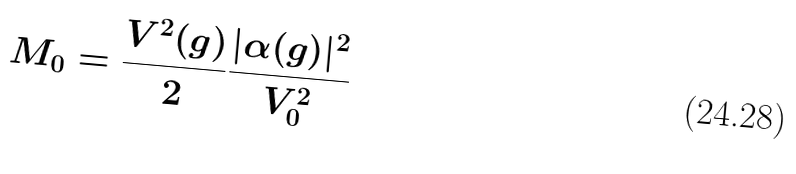<formula> <loc_0><loc_0><loc_500><loc_500>M _ { 0 } = \frac { V ^ { 2 } ( g ) } { 2 } \frac { | \alpha ( g ) | ^ { 2 } } { V _ { 0 } ^ { 2 } }</formula> 